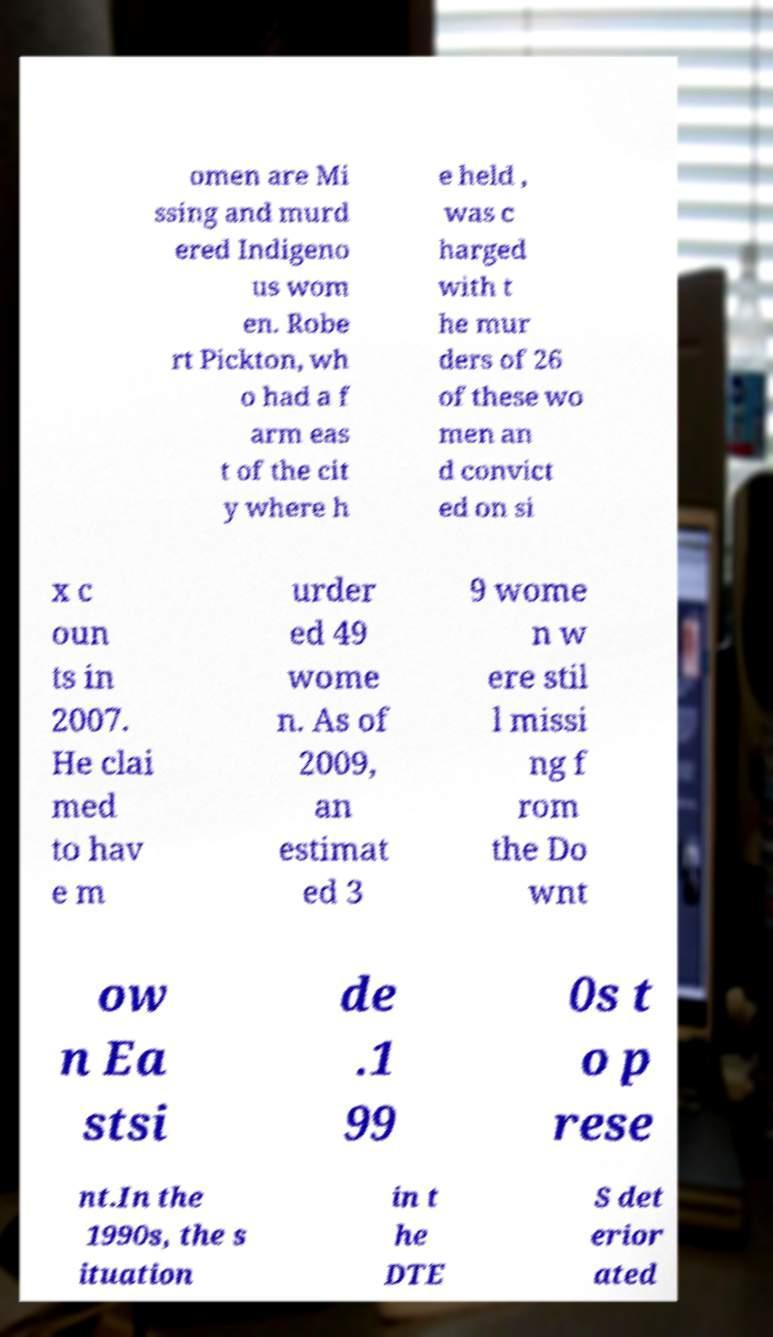Please identify and transcribe the text found in this image. omen are Mi ssing and murd ered Indigeno us wom en. Robe rt Pickton, wh o had a f arm eas t of the cit y where h e held , was c harged with t he mur ders of 26 of these wo men an d convict ed on si x c oun ts in 2007. He clai med to hav e m urder ed 49 wome n. As of 2009, an estimat ed 3 9 wome n w ere stil l missi ng f rom the Do wnt ow n Ea stsi de .1 99 0s t o p rese nt.In the 1990s, the s ituation in t he DTE S det erior ated 